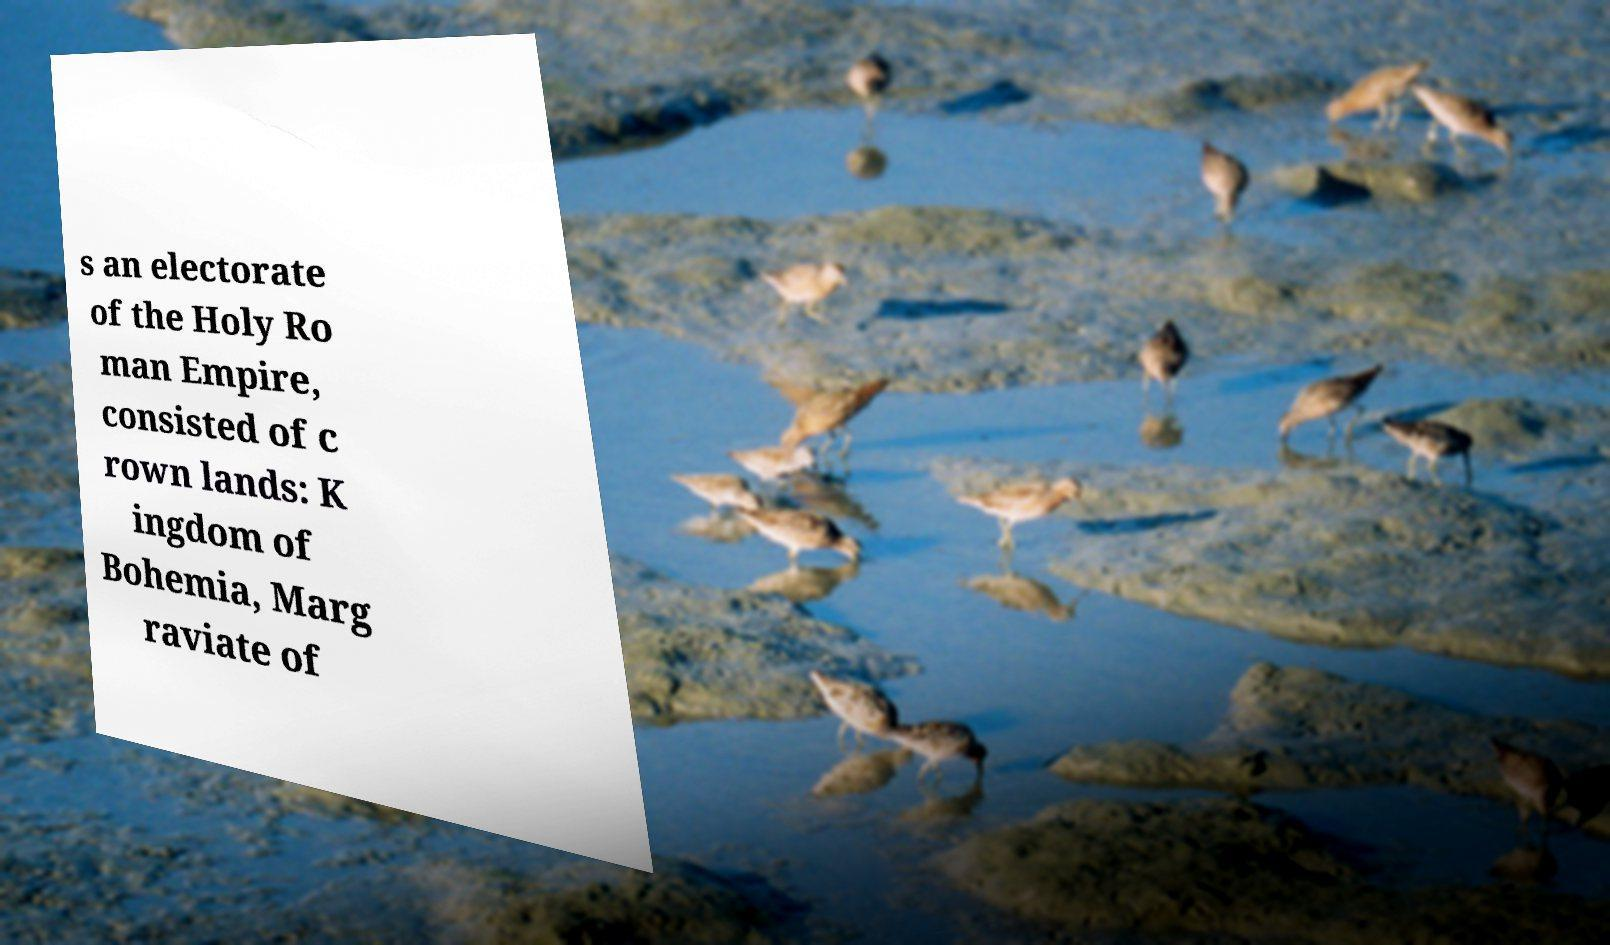What messages or text are displayed in this image? I need them in a readable, typed format. s an electorate of the Holy Ro man Empire, consisted of c rown lands: K ingdom of Bohemia, Marg raviate of 